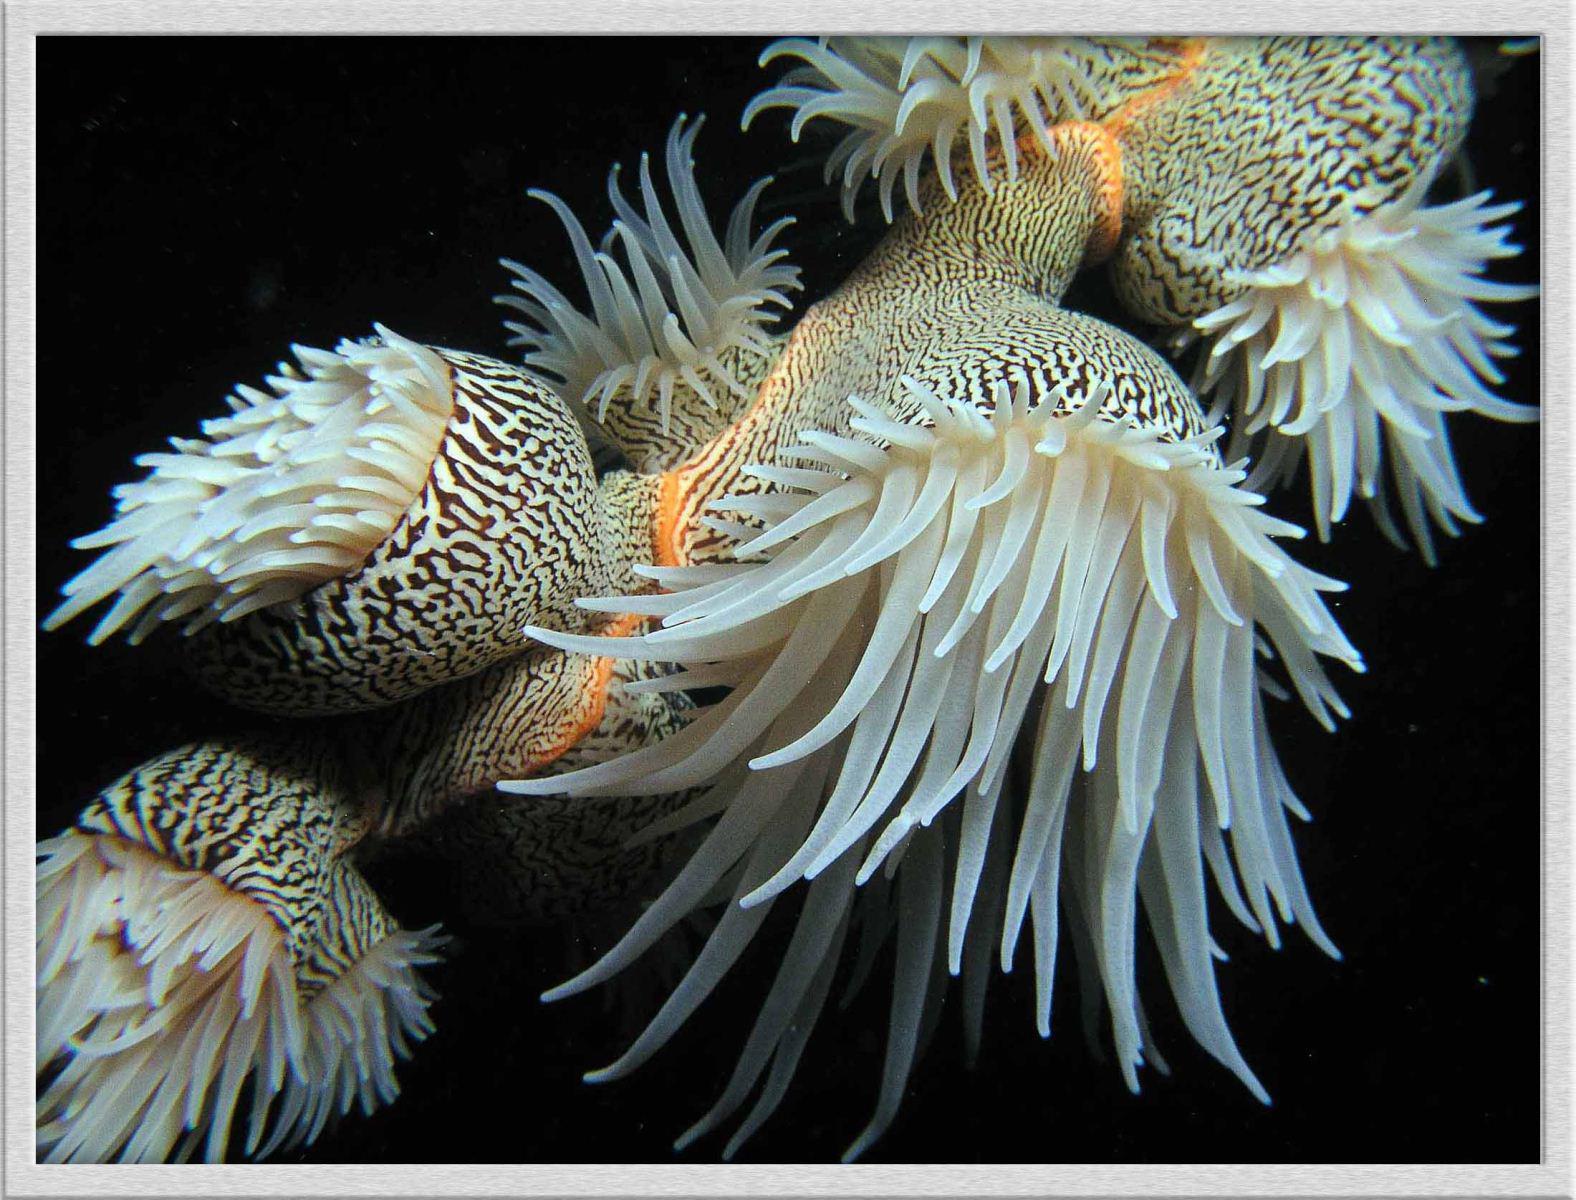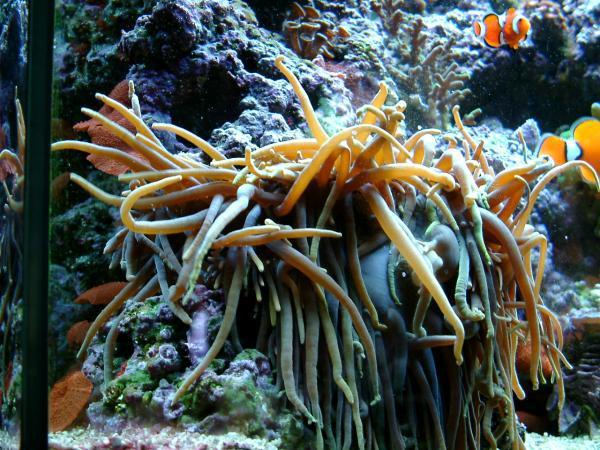The first image is the image on the left, the second image is the image on the right. Assess this claim about the two images: "There are no fish in the left image.". Correct or not? Answer yes or no. Yes. The first image is the image on the left, the second image is the image on the right. Examine the images to the left and right. Is the description "The left image shows clown fish swimming in the noodle-like yellowish tendrils of anemone." accurate? Answer yes or no. No. 